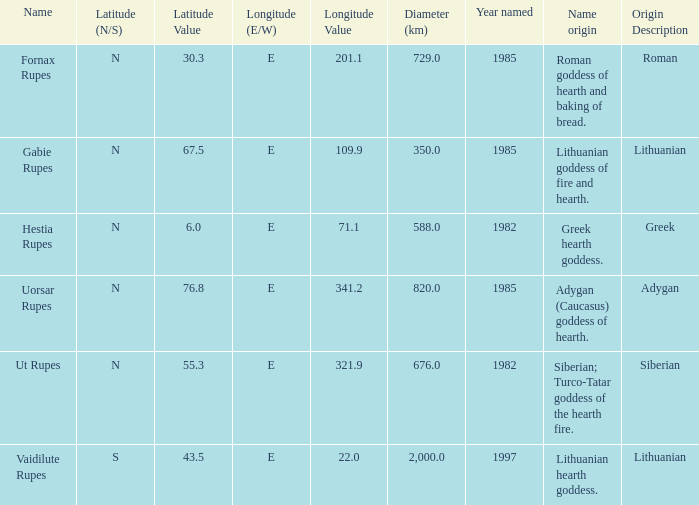At a longitude of 10 1.0. 